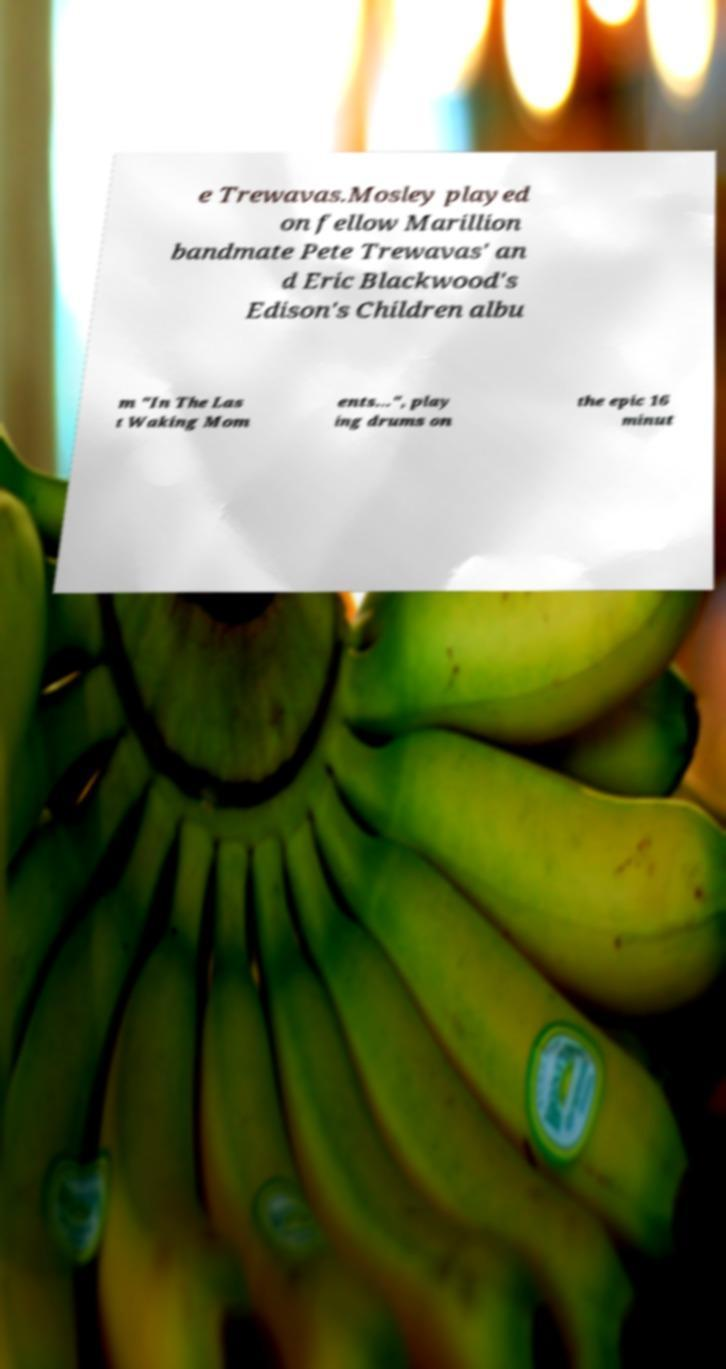Can you accurately transcribe the text from the provided image for me? e Trewavas.Mosley played on fellow Marillion bandmate Pete Trewavas' an d Eric Blackwood's Edison's Children albu m "In The Las t Waking Mom ents...", play ing drums on the epic 16 minut 